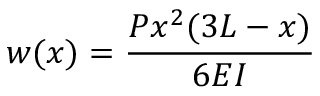<formula> <loc_0><loc_0><loc_500><loc_500>w ( x ) = { \frac { P x ^ { 2 } ( 3 L - x ) } { 6 E I } }</formula> 